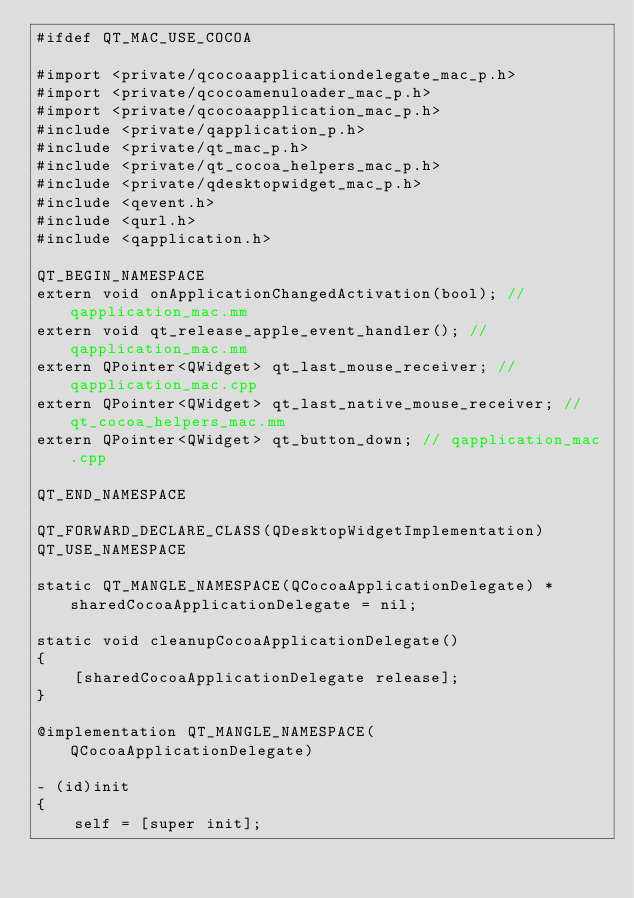Convert code to text. <code><loc_0><loc_0><loc_500><loc_500><_ObjectiveC_>#ifdef QT_MAC_USE_COCOA

#import <private/qcocoaapplicationdelegate_mac_p.h>
#import <private/qcocoamenuloader_mac_p.h>
#import <private/qcocoaapplication_mac_p.h>
#include <private/qapplication_p.h>
#include <private/qt_mac_p.h>
#include <private/qt_cocoa_helpers_mac_p.h>
#include <private/qdesktopwidget_mac_p.h>
#include <qevent.h>
#include <qurl.h>
#include <qapplication.h>

QT_BEGIN_NAMESPACE
extern void onApplicationChangedActivation(bool); // qapplication_mac.mm
extern void qt_release_apple_event_handler(); //qapplication_mac.mm
extern QPointer<QWidget> qt_last_mouse_receiver; // qapplication_mac.cpp
extern QPointer<QWidget> qt_last_native_mouse_receiver; // qt_cocoa_helpers_mac.mm
extern QPointer<QWidget> qt_button_down; // qapplication_mac.cpp

QT_END_NAMESPACE

QT_FORWARD_DECLARE_CLASS(QDesktopWidgetImplementation)
QT_USE_NAMESPACE

static QT_MANGLE_NAMESPACE(QCocoaApplicationDelegate) *sharedCocoaApplicationDelegate = nil;

static void cleanupCocoaApplicationDelegate()
{
    [sharedCocoaApplicationDelegate release];
}

@implementation QT_MANGLE_NAMESPACE(QCocoaApplicationDelegate)

- (id)init
{
    self = [super init];</code> 